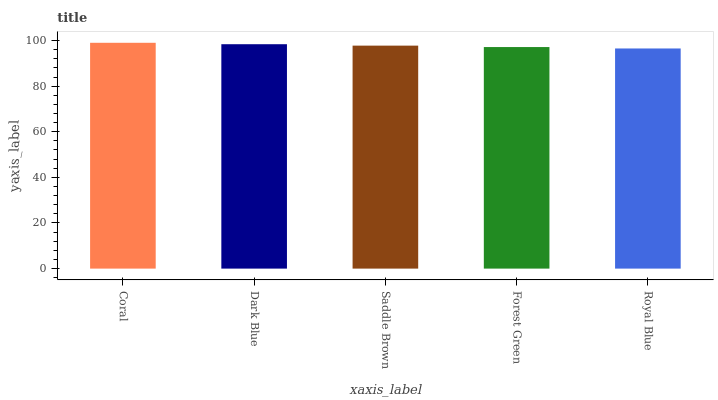Is Dark Blue the minimum?
Answer yes or no. No. Is Dark Blue the maximum?
Answer yes or no. No. Is Coral greater than Dark Blue?
Answer yes or no. Yes. Is Dark Blue less than Coral?
Answer yes or no. Yes. Is Dark Blue greater than Coral?
Answer yes or no. No. Is Coral less than Dark Blue?
Answer yes or no. No. Is Saddle Brown the high median?
Answer yes or no. Yes. Is Saddle Brown the low median?
Answer yes or no. Yes. Is Forest Green the high median?
Answer yes or no. No. Is Royal Blue the low median?
Answer yes or no. No. 